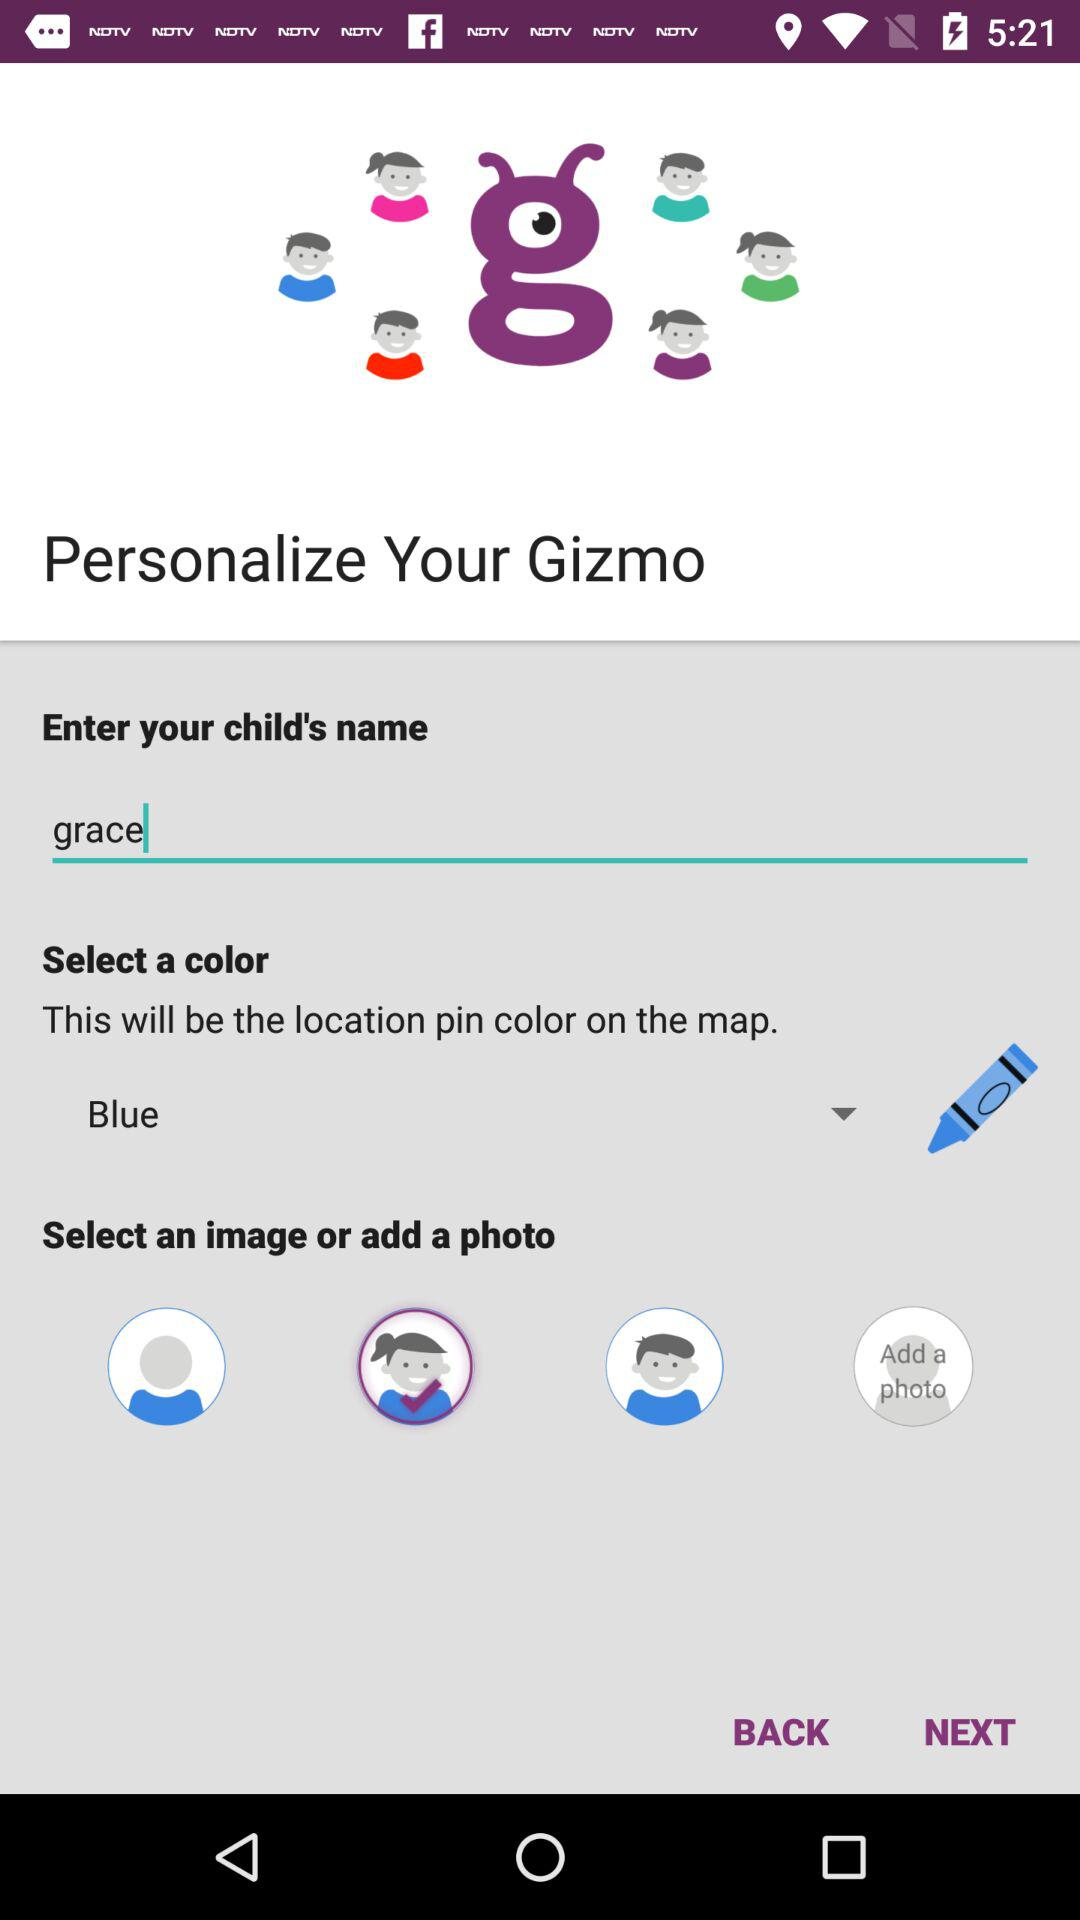What's the selected color? The selected color is blue. 